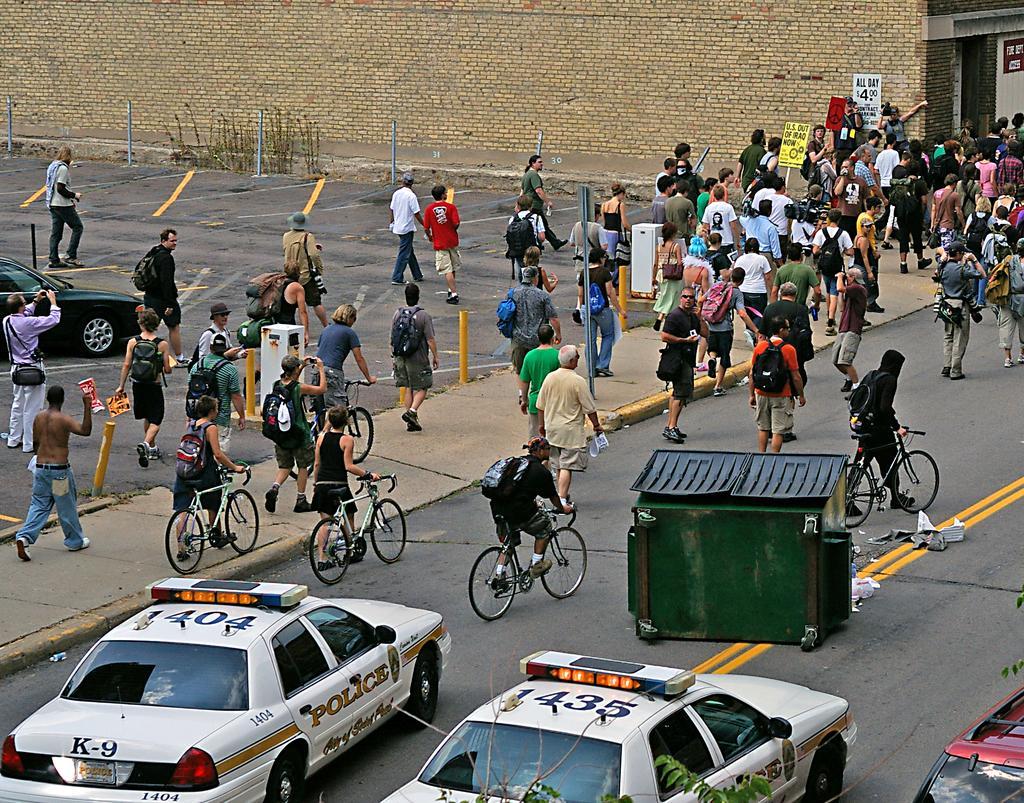In one or two sentences, can you explain what this image depicts? In this image we can see a group of people walking on the road and some of them are riding bicycles and few of them are holding bicycles, there are a few cars, few poles and a green color object on the middle of the road, there are few board and a building. 